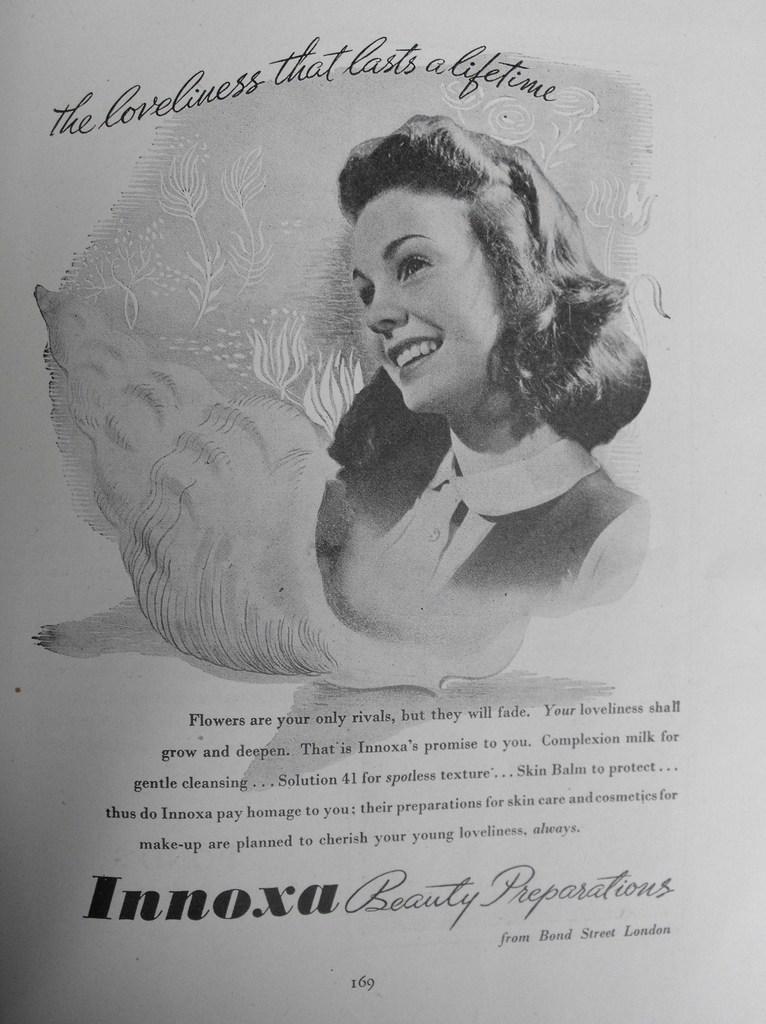Can you describe this image briefly? In this image there is a person, there is text, there is a number, the background of the image is white in color. 